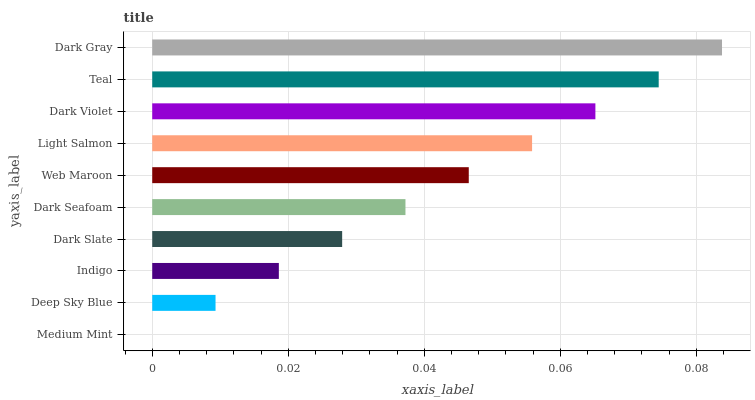Is Medium Mint the minimum?
Answer yes or no. Yes. Is Dark Gray the maximum?
Answer yes or no. Yes. Is Deep Sky Blue the minimum?
Answer yes or no. No. Is Deep Sky Blue the maximum?
Answer yes or no. No. Is Deep Sky Blue greater than Medium Mint?
Answer yes or no. Yes. Is Medium Mint less than Deep Sky Blue?
Answer yes or no. Yes. Is Medium Mint greater than Deep Sky Blue?
Answer yes or no. No. Is Deep Sky Blue less than Medium Mint?
Answer yes or no. No. Is Web Maroon the high median?
Answer yes or no. Yes. Is Dark Seafoam the low median?
Answer yes or no. Yes. Is Deep Sky Blue the high median?
Answer yes or no. No. Is Teal the low median?
Answer yes or no. No. 